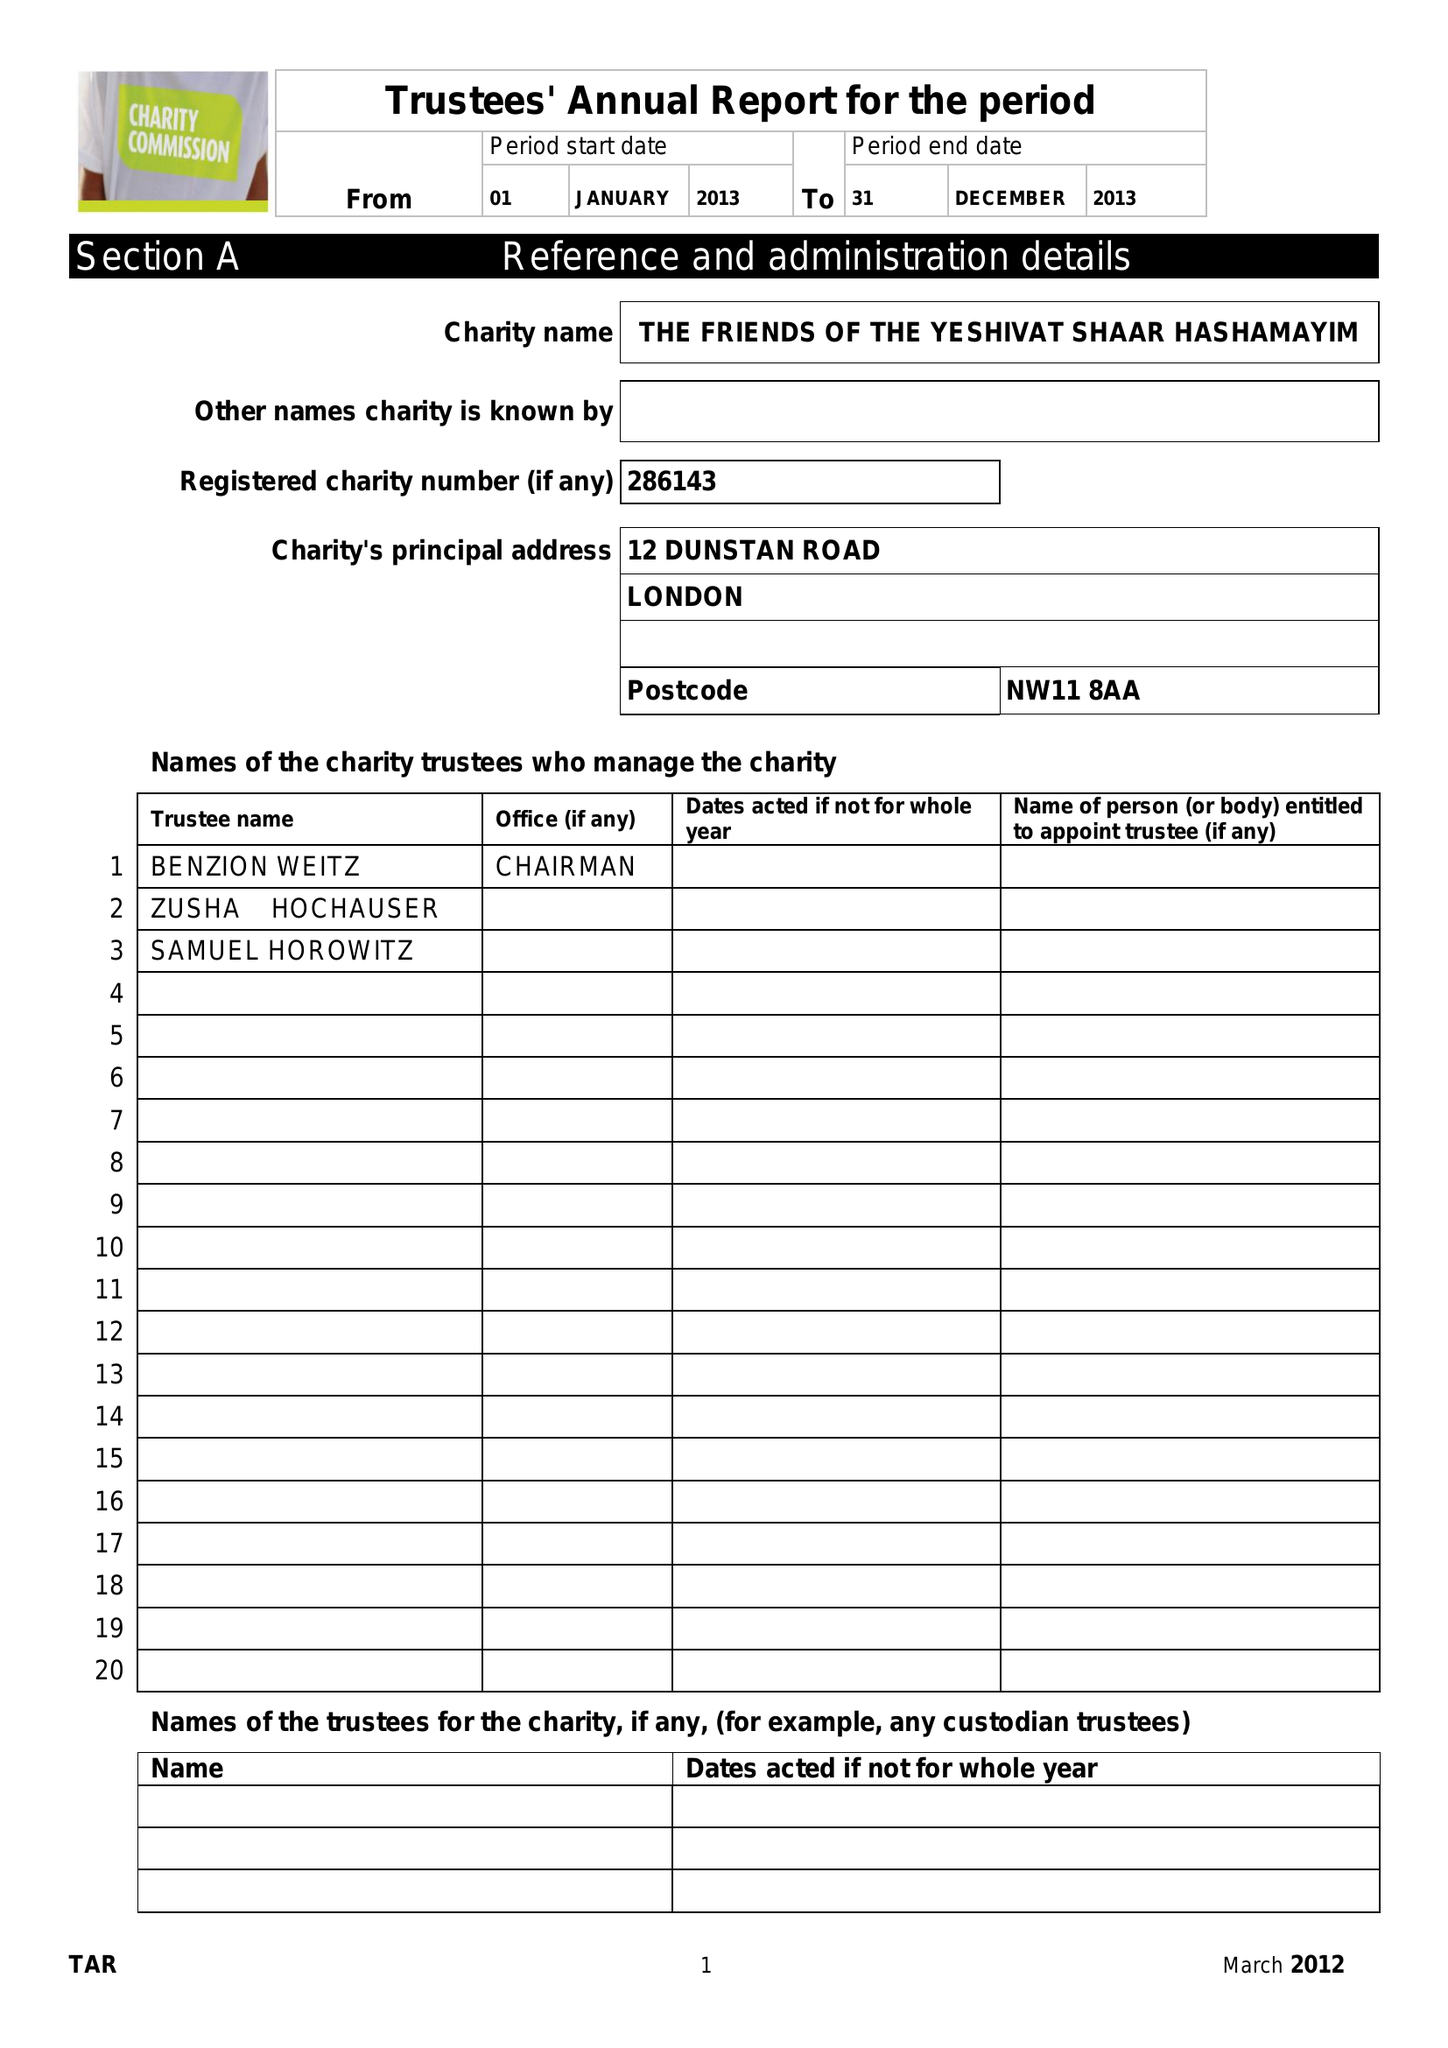What is the value for the address__postcode?
Answer the question using a single word or phrase. NW11 8AA 